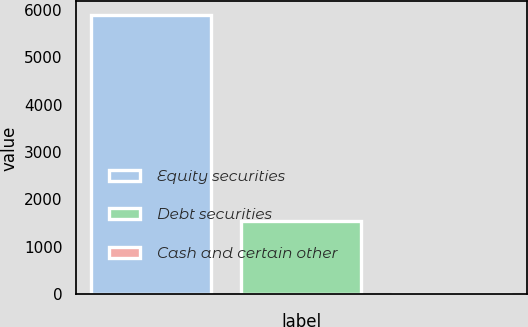<chart> <loc_0><loc_0><loc_500><loc_500><bar_chart><fcel>Equity securities<fcel>Debt securities<fcel>Cash and certain other<nl><fcel>5885<fcel>1542<fcel>5<nl></chart> 